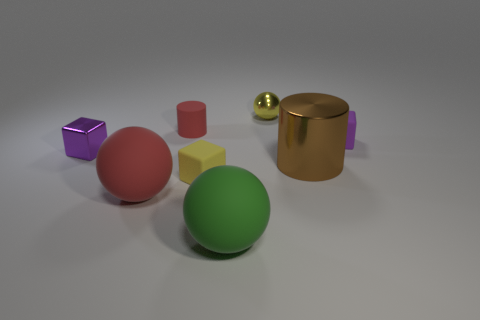What shape is the large thing that is on the right side of the sphere in front of the big red ball?
Your answer should be very brief. Cylinder. What is the color of the tiny shiny sphere?
Provide a short and direct response. Yellow. How many other objects are the same size as the brown shiny cylinder?
Provide a short and direct response. 2. There is a ball that is both in front of the metal cube and behind the big green matte ball; what is its material?
Provide a short and direct response. Rubber. Is the size of the red object that is behind the yellow rubber cube the same as the tiny purple rubber block?
Offer a terse response. Yes. Does the metallic ball have the same color as the big metallic cylinder?
Your response must be concise. No. What number of objects are both to the right of the metallic cylinder and in front of the small yellow matte thing?
Your answer should be compact. 0. There is a cylinder in front of the small purple object that is to the left of the brown cylinder; how many large brown shiny things are right of it?
Provide a succinct answer. 0. What is the size of the object that is the same color as the metallic sphere?
Ensure brevity in your answer.  Small. There is a large red rubber object; what shape is it?
Your answer should be very brief. Sphere. 